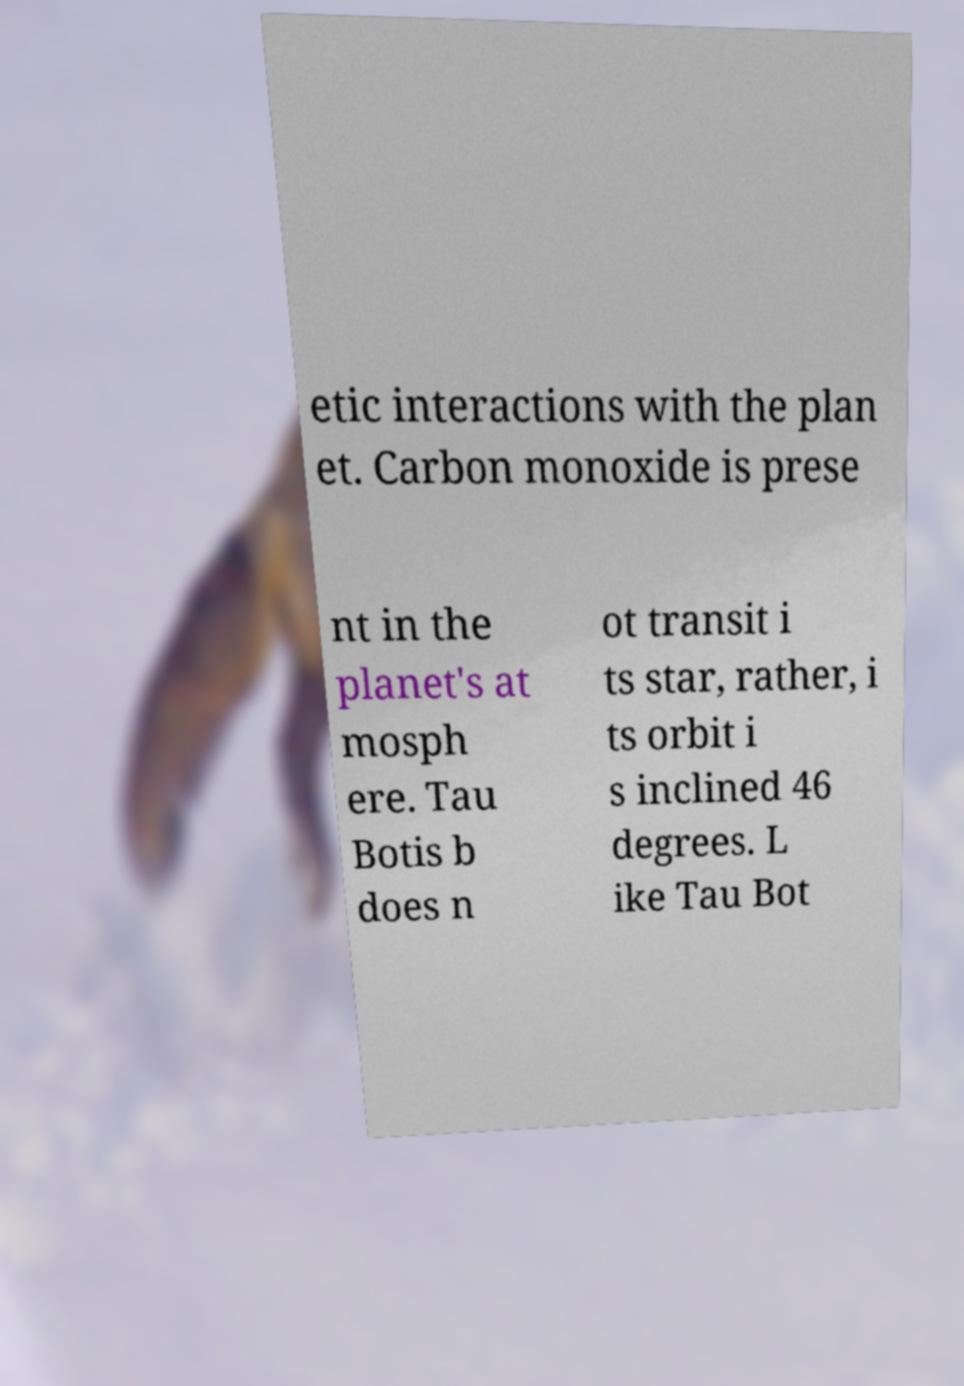Please identify and transcribe the text found in this image. etic interactions with the plan et. Carbon monoxide is prese nt in the planet's at mosph ere. Tau Botis b does n ot transit i ts star, rather, i ts orbit i s inclined 46 degrees. L ike Tau Bot 